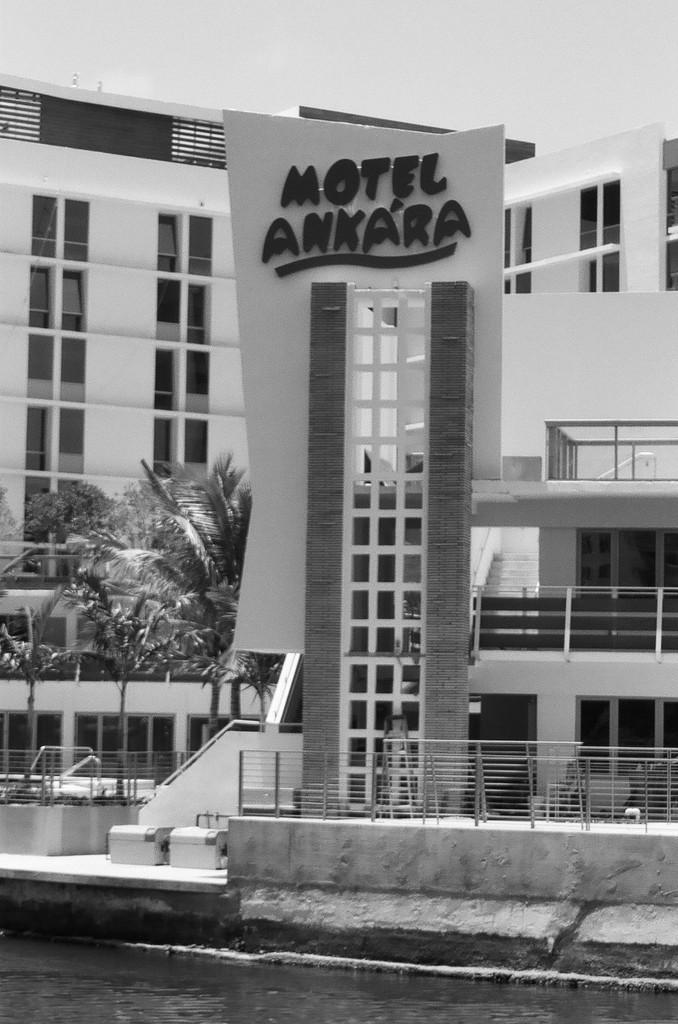What can be seen in the image that is related to water? There is water visible in the image. What type of structures are present in the image? There are fences, a wall, a board, and buildings in the image. What type of vegetation is present in the image? There are trees in the image. What is visible in the background of the image? The sky is visible in the background of the image. Can you see a boy attacking a pie in the image? There is no boy or pie present in the image. What type of attack is happening in the image? There is no attack present in the image; it features water, fences, a wall, a board, buildings, trees, and the sky. 